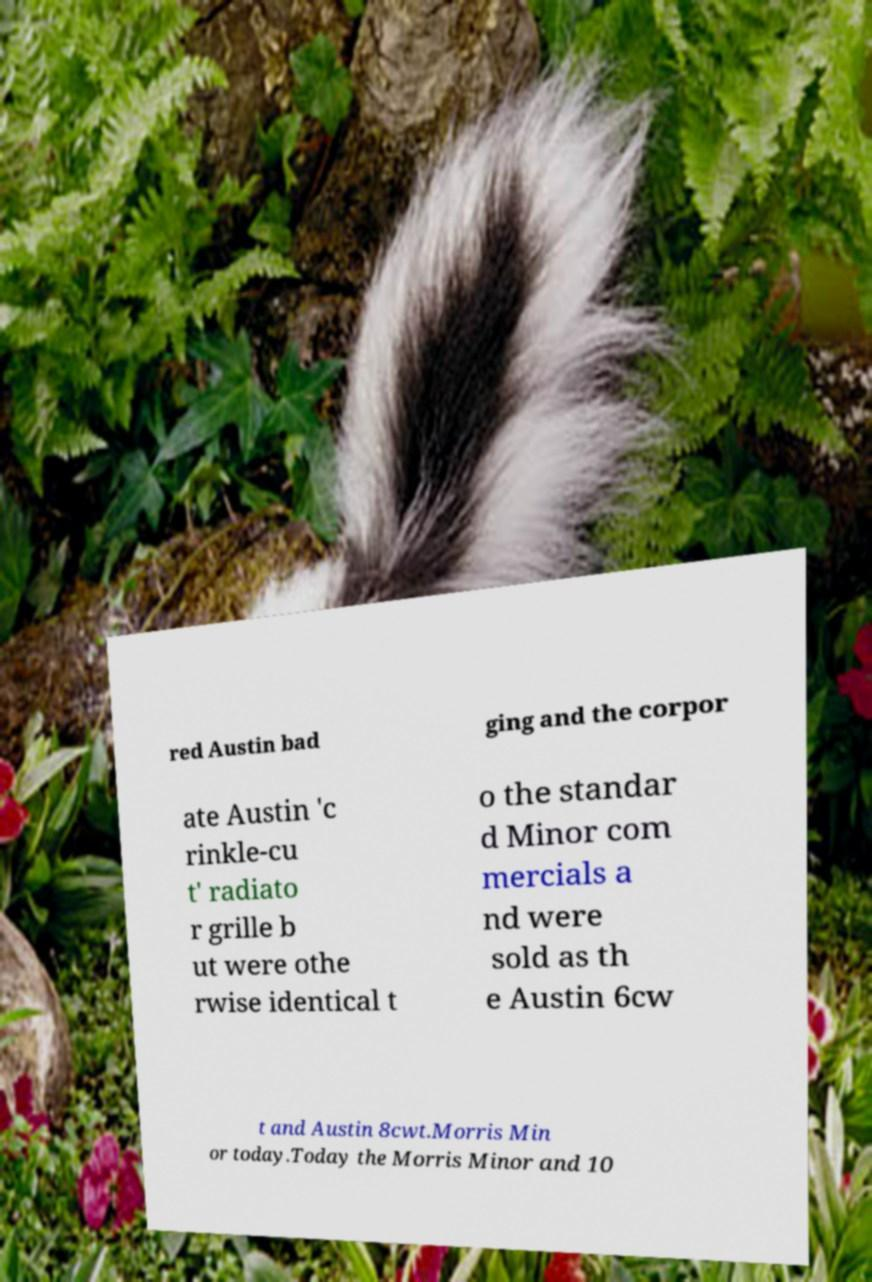Can you read and provide the text displayed in the image?This photo seems to have some interesting text. Can you extract and type it out for me? red Austin bad ging and the corpor ate Austin 'c rinkle-cu t' radiato r grille b ut were othe rwise identical t o the standar d Minor com mercials a nd were sold as th e Austin 6cw t and Austin 8cwt.Morris Min or today.Today the Morris Minor and 10 